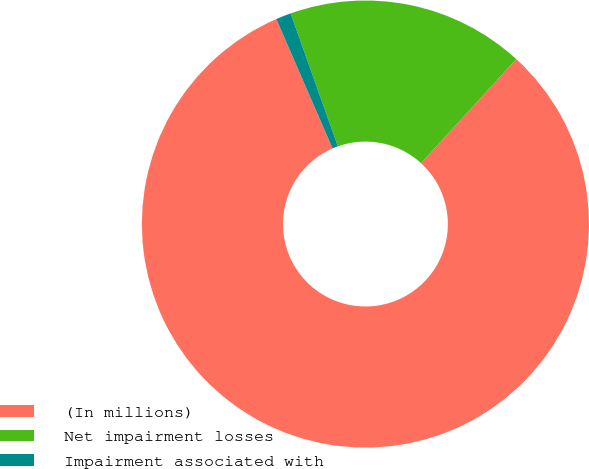Convert chart. <chart><loc_0><loc_0><loc_500><loc_500><pie_chart><fcel>(In millions)<fcel>Net impairment losses<fcel>Impairment associated with<nl><fcel>81.69%<fcel>17.22%<fcel>1.1%<nl></chart> 